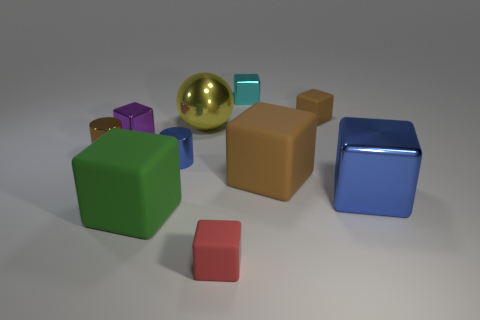Do the large metallic block and the metallic cylinder right of the large green matte cube have the same color?
Provide a short and direct response. Yes. How many other objects are the same shape as the green object?
Keep it short and to the point. 6. What number of objects are big metal blocks or small brown objects that are on the right side of the tiny brown cylinder?
Your response must be concise. 2. Is the number of yellow metallic things that are on the right side of the big green thing greater than the number of big matte things behind the tiny brown rubber block?
Provide a succinct answer. Yes. There is a tiny metallic object that is in front of the cylinder that is behind the cylinder that is on the right side of the large green matte block; what shape is it?
Ensure brevity in your answer.  Cylinder. There is a blue metal thing behind the shiny object that is to the right of the large brown matte block; what shape is it?
Make the answer very short. Cylinder. Is there a blue cylinder made of the same material as the purple thing?
Ensure brevity in your answer.  Yes. What number of brown objects are either metal spheres or large matte cubes?
Keep it short and to the point. 1. Is there a object of the same color as the big shiny block?
Offer a very short reply. Yes. What is the size of the cyan block that is made of the same material as the purple cube?
Provide a succinct answer. Small. 